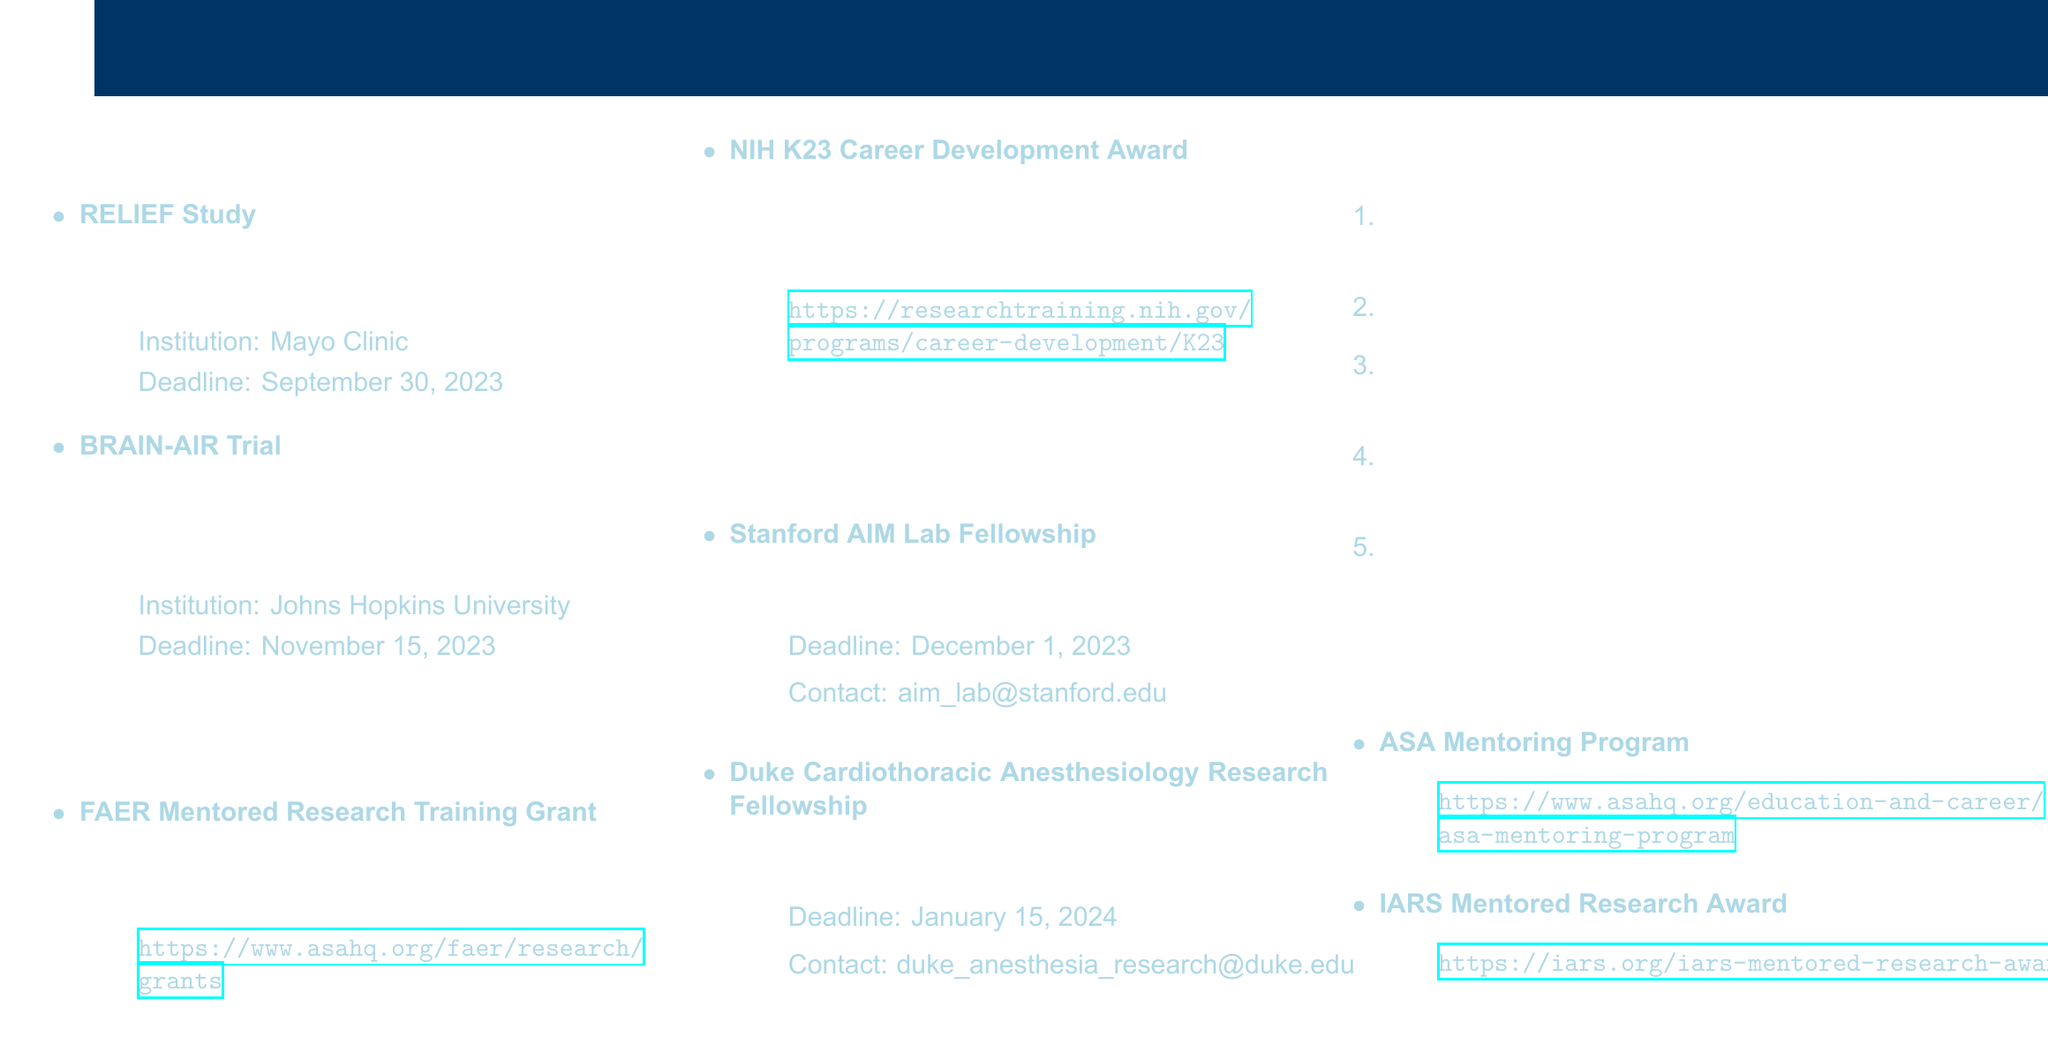What is the deadline for the RELIEF Study? The deadline for the RELIEF Study is mentioned in the document, which states September 30, 2023.
Answer: September 30, 2023 What is the funding amount for the NIH K23 Career Development Award? The funding amount for the NIH K23 Career Development Award is specified as up to $600,000 in the document.
Answer: Up to $600,000 Which institution is conducting the BRAIN-AIR Trial? The document lists Johns Hopkins University as the institution conducting the BRAIN-AIR Trial.
Answer: Johns Hopkins University How long is the duration for the FAER Mentored Research Training Grant? The duration for the FAER Mentored Research Training Grant is detailed in the document, specifying a period of 2 years.
Answer: 2 years What is the application deadline for the Duke Cardiothoracic Anesthesiology Research Fellowship? The application deadline for the Duke Cardiothoracic Anesthesiology Research Fellowship is stated as January 15, 2024.
Answer: January 15, 2024 What is the first step in the application procedures? The document outlines the application procedures, starting with the step to identify a suitable research opportunity or clinical trial.
Answer: Identify suitable research opportunity or clinical trial Which fellowship has the contact email aim_lab@stanford.edu? The document lists the Stanford AIM Lab Fellowship with the provided contact email for inquiries, indicating the specific fellowship.
Answer: Stanford AIM Lab Fellowship What program is mentioned as an additional resource for mentorship? In the additional resources section, the ASA Mentoring Program is highlighted as a supportive resource for mentorship opportunities.
Answer: ASA Mentoring Program How many clinical trials are listed in the document? The document contains two ongoing clinical trials, as mentioned in the section heading.
Answer: 2 